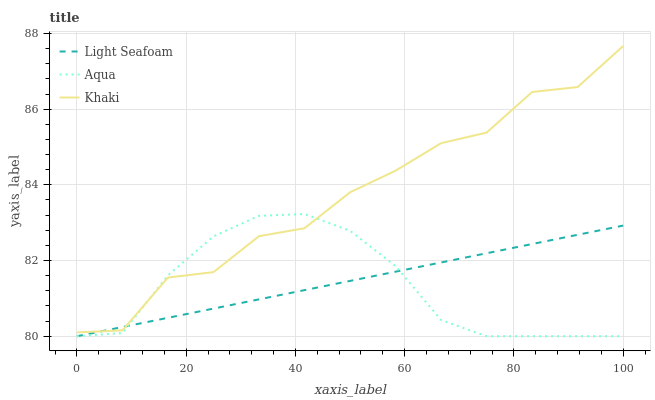Does Khaki have the minimum area under the curve?
Answer yes or no. No. Does Aqua have the maximum area under the curve?
Answer yes or no. No. Is Aqua the smoothest?
Answer yes or no. No. Is Aqua the roughest?
Answer yes or no. No. Does Khaki have the lowest value?
Answer yes or no. No. Does Aqua have the highest value?
Answer yes or no. No. 